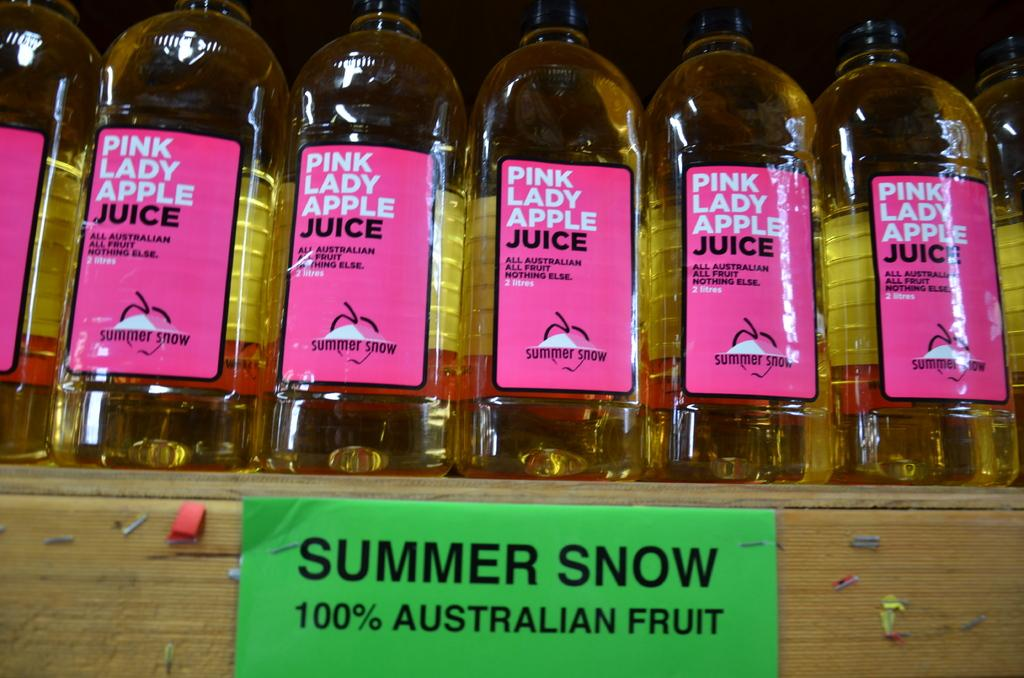<image>
Describe the image concisely. Bottles of Pink Lady Apple Juice are lined up on a shelf 